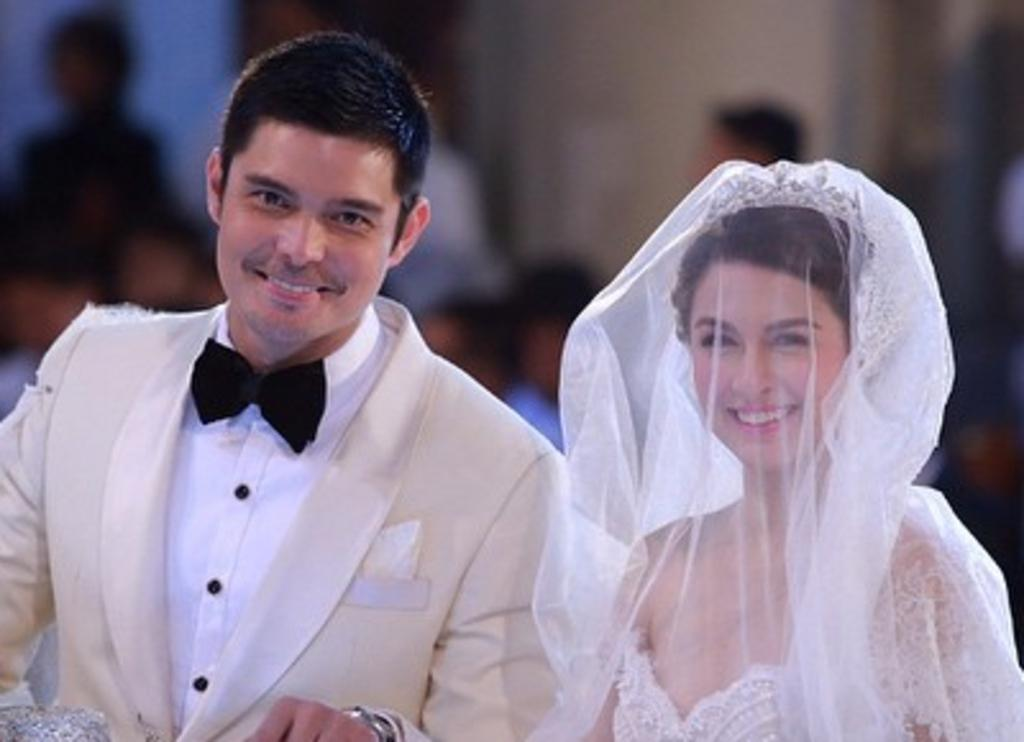Who are the two people in the image? There is a married couple in the image, consisting of a bride and a groom. Where is the bride positioned in the image? The bride is on the right side of the image. What is the bride wearing in the image? The bride is wearing a white gown and a veil. Where is the groom positioned in the image? The groom is on the left side of the image. What is the groom wearing in the image? The groom is wearing a suit and a black bow. Can you describe the background of the image? The background of the image is blurred. What type of sign can be seen in the image? There is no sign present in the image. What kind of jewel is the bride wearing on her head? The bride is wearing a veil, not a jewel, on her head. How many cats are visible in the image? There are no cats present in the image. 